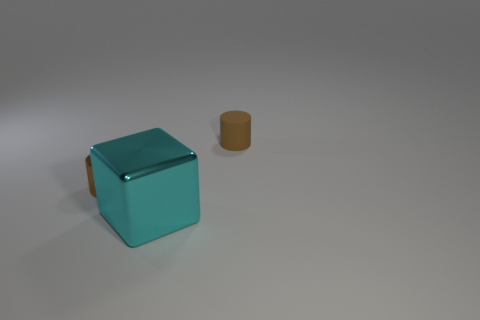Add 1 big cyan metallic things. How many objects exist? 4 Subtract all purple cylinders. Subtract all yellow spheres. How many cylinders are left? 2 Subtract all cylinders. How many objects are left? 1 Subtract 1 cyan blocks. How many objects are left? 2 Subtract all small brown shiny spheres. Subtract all brown metallic cylinders. How many objects are left? 2 Add 2 big cyan things. How many big cyan things are left? 3 Add 3 large gray metallic cylinders. How many large gray metallic cylinders exist? 3 